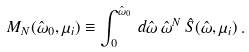Convert formula to latex. <formula><loc_0><loc_0><loc_500><loc_500>M _ { N } ( \hat { \omega } _ { 0 } , \mu _ { i } ) \equiv \int _ { 0 } ^ { \hat { \omega } _ { 0 } } \, d \hat { \omega } \, \hat { \omega } ^ { N } \, \hat { S } ( \hat { \omega } , \mu _ { i } ) \, .</formula> 